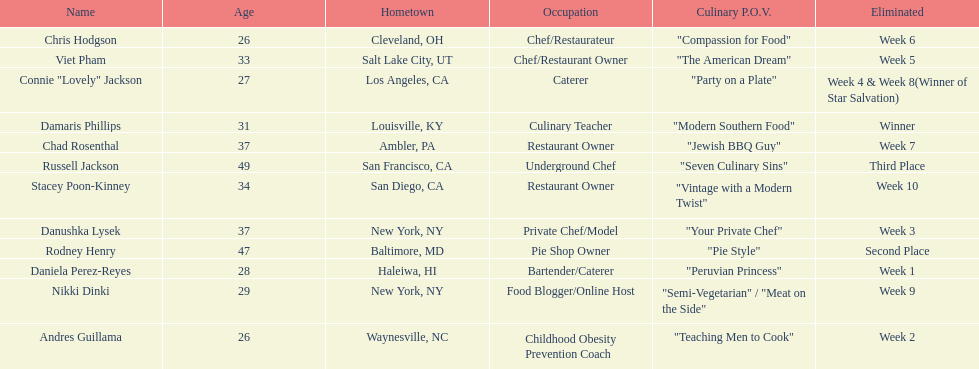Who was the first contestant to be eliminated on season 9 of food network star? Daniela Perez-Reyes. 